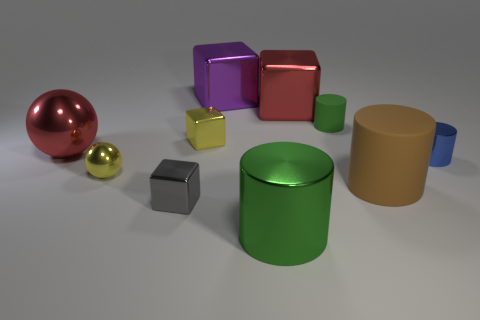How many other objects are the same color as the tiny rubber cylinder?
Ensure brevity in your answer.  1. How many red spheres are the same material as the big green cylinder?
Ensure brevity in your answer.  1. There is a shiny cylinder in front of the tiny blue thing; is its color the same as the tiny rubber object?
Your response must be concise. Yes. How many red objects are either large metallic cylinders or large metallic cubes?
Give a very brief answer. 1. Are the green cylinder that is in front of the big red metal ball and the yellow block made of the same material?
Your answer should be very brief. Yes. What number of things are small metal objects or yellow objects in front of the blue metallic object?
Your answer should be compact. 4. There is a tiny thing right of the matte cylinder behind the big brown rubber cylinder; how many red cubes are in front of it?
Offer a terse response. 0. Do the big red thing that is on the right side of the gray thing and the purple metal object have the same shape?
Offer a terse response. Yes. Is there a large thing on the right side of the red thing that is to the right of the large red sphere?
Ensure brevity in your answer.  Yes. How many cylinders are there?
Make the answer very short. 4. 